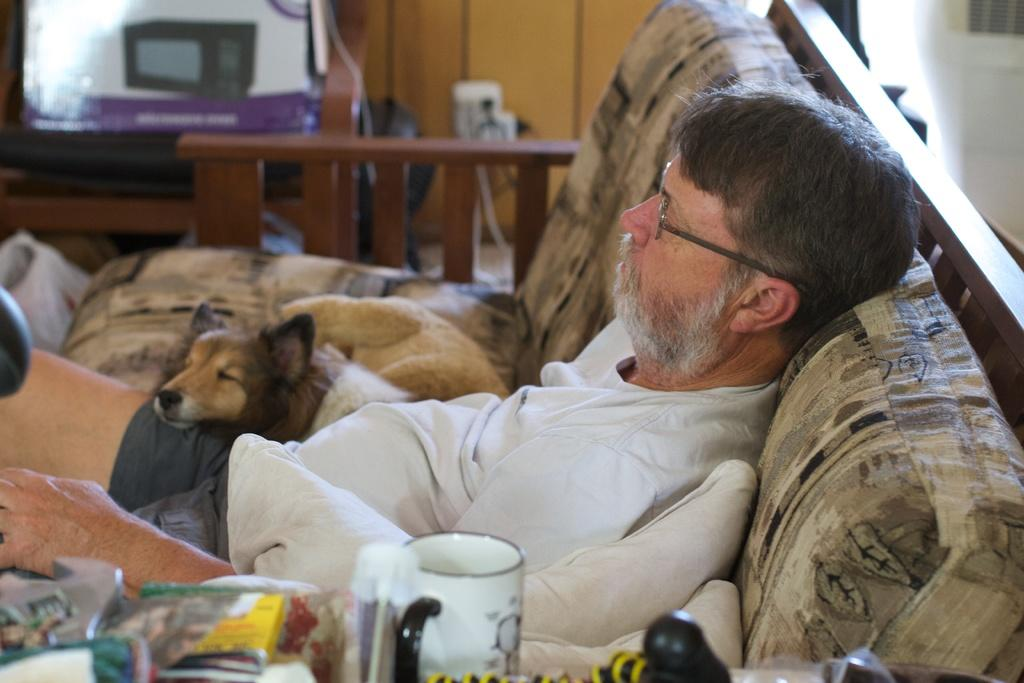What is the person in the image doing? There is a person sitting on a sofa in the image. What can be seen beside the person on the sofa? There is a dog beside the person in the image. What type of chain is the person wearing around their neck in the image? There is no chain visible around the person's neck in the image. How many rings can be seen on the dog's paws in the image? There are no rings present on the dog's paws in the image. 